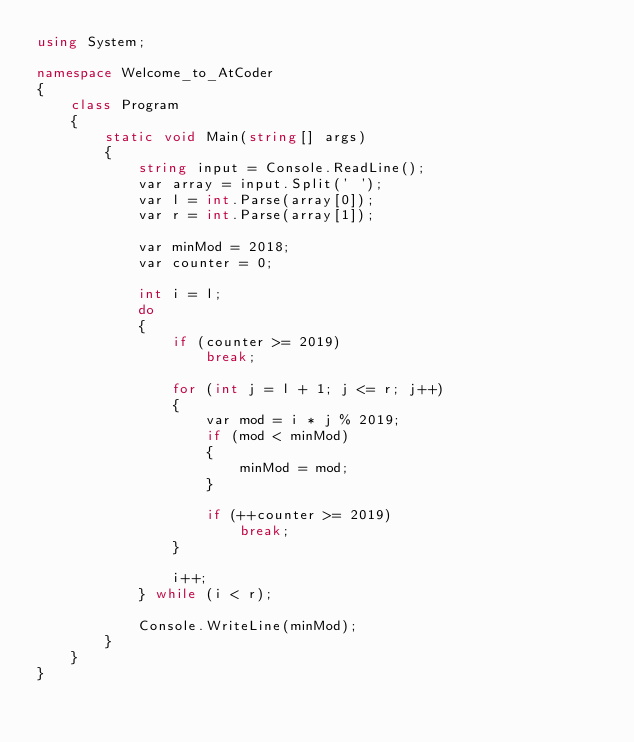Convert code to text. <code><loc_0><loc_0><loc_500><loc_500><_C#_>using System;

namespace Welcome_to_AtCoder
{
    class Program
    {
        static void Main(string[] args)
        {
            string input = Console.ReadLine();
            var array = input.Split(' ');
            var l = int.Parse(array[0]);
            var r = int.Parse(array[1]);

            var minMod = 2018;
            var counter = 0;

            int i = l;
            do
            {
                if (counter >= 2019)
                    break;

                for (int j = l + 1; j <= r; j++)
                {
                    var mod = i * j % 2019;
                    if (mod < minMod)
                    {
                        minMod = mod;
                    }

                    if (++counter >= 2019)
                        break;
                }

                i++;
            } while (i < r);

            Console.WriteLine(minMod);
        }
    }
}
</code> 